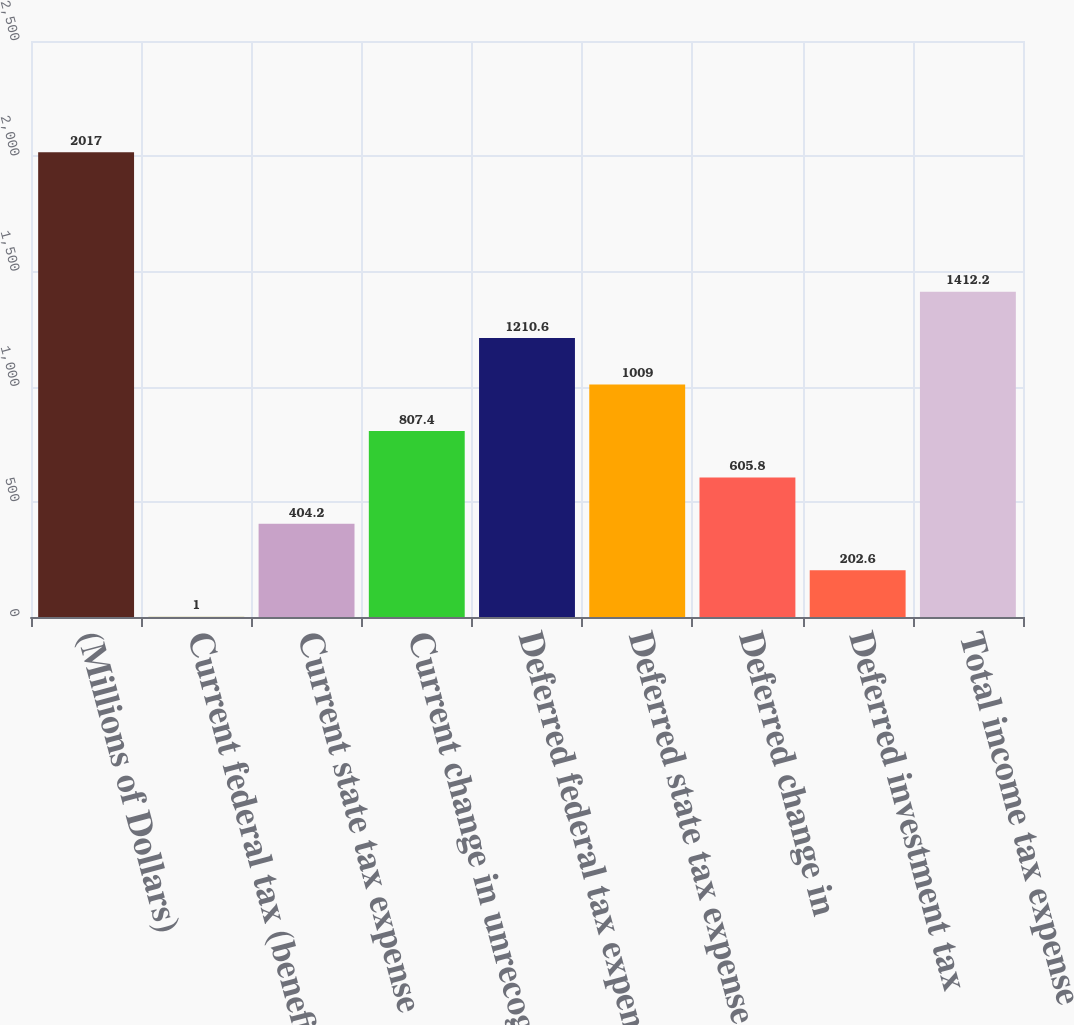<chart> <loc_0><loc_0><loc_500><loc_500><bar_chart><fcel>(Millions of Dollars)<fcel>Current federal tax (benefit)<fcel>Current state tax expense<fcel>Current change in unrecognized<fcel>Deferred federal tax expense<fcel>Deferred state tax expense<fcel>Deferred change in<fcel>Deferred investment tax<fcel>Total income tax expense<nl><fcel>2017<fcel>1<fcel>404.2<fcel>807.4<fcel>1210.6<fcel>1009<fcel>605.8<fcel>202.6<fcel>1412.2<nl></chart> 